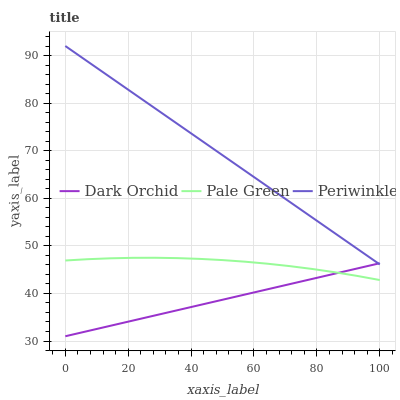Does Dark Orchid have the minimum area under the curve?
Answer yes or no. Yes. Does Periwinkle have the maximum area under the curve?
Answer yes or no. Yes. Does Periwinkle have the minimum area under the curve?
Answer yes or no. No. Does Dark Orchid have the maximum area under the curve?
Answer yes or no. No. Is Dark Orchid the smoothest?
Answer yes or no. Yes. Is Pale Green the roughest?
Answer yes or no. Yes. Is Periwinkle the smoothest?
Answer yes or no. No. Is Periwinkle the roughest?
Answer yes or no. No. Does Dark Orchid have the lowest value?
Answer yes or no. Yes. Does Periwinkle have the lowest value?
Answer yes or no. No. Does Periwinkle have the highest value?
Answer yes or no. Yes. Does Dark Orchid have the highest value?
Answer yes or no. No. Is Pale Green less than Periwinkle?
Answer yes or no. Yes. Is Periwinkle greater than Pale Green?
Answer yes or no. Yes. Does Dark Orchid intersect Periwinkle?
Answer yes or no. Yes. Is Dark Orchid less than Periwinkle?
Answer yes or no. No. Is Dark Orchid greater than Periwinkle?
Answer yes or no. No. Does Pale Green intersect Periwinkle?
Answer yes or no. No. 